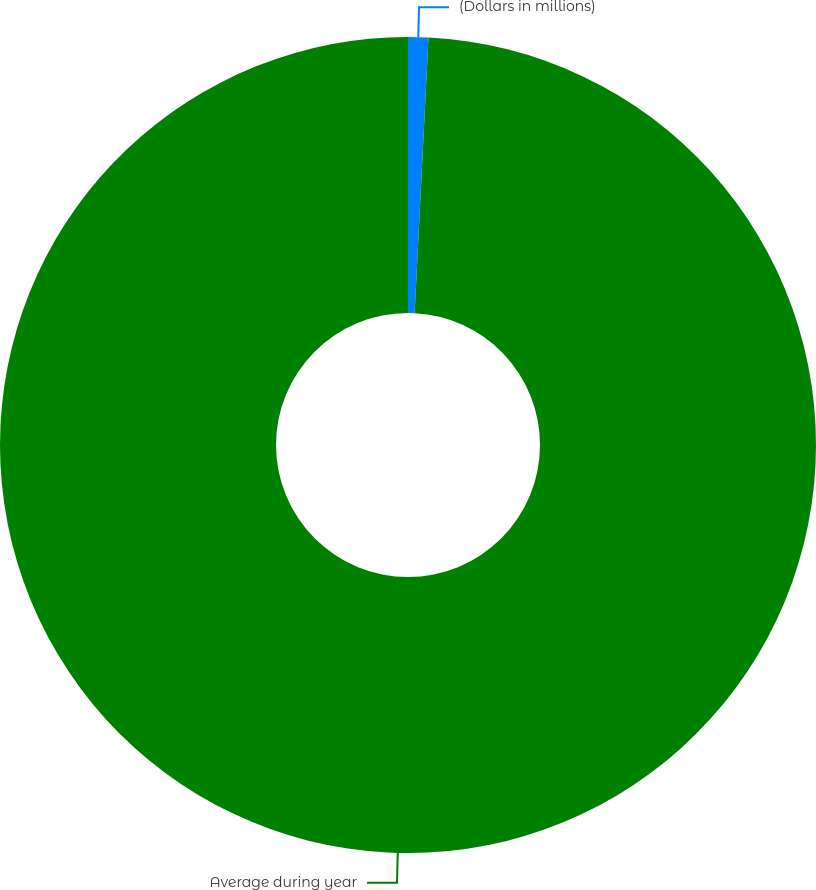Convert chart. <chart><loc_0><loc_0><loc_500><loc_500><pie_chart><fcel>(Dollars in millions)<fcel>Average during year<nl><fcel>0.8%<fcel>99.2%<nl></chart> 